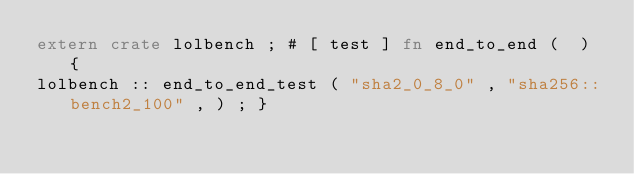<code> <loc_0><loc_0><loc_500><loc_500><_Rust_>extern crate lolbench ; # [ test ] fn end_to_end (  ) {
lolbench :: end_to_end_test ( "sha2_0_8_0" , "sha256::bench2_100" , ) ; }</code> 